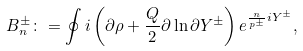<formula> <loc_0><loc_0><loc_500><loc_500>B _ { n } ^ { \pm } \colon = \oint i \left ( \partial \rho + \frac { Q } { 2 } \partial \ln \partial Y ^ { \pm } \right ) e ^ { \frac { n } { p ^ { \pm } } i Y ^ { \pm } } ,</formula> 